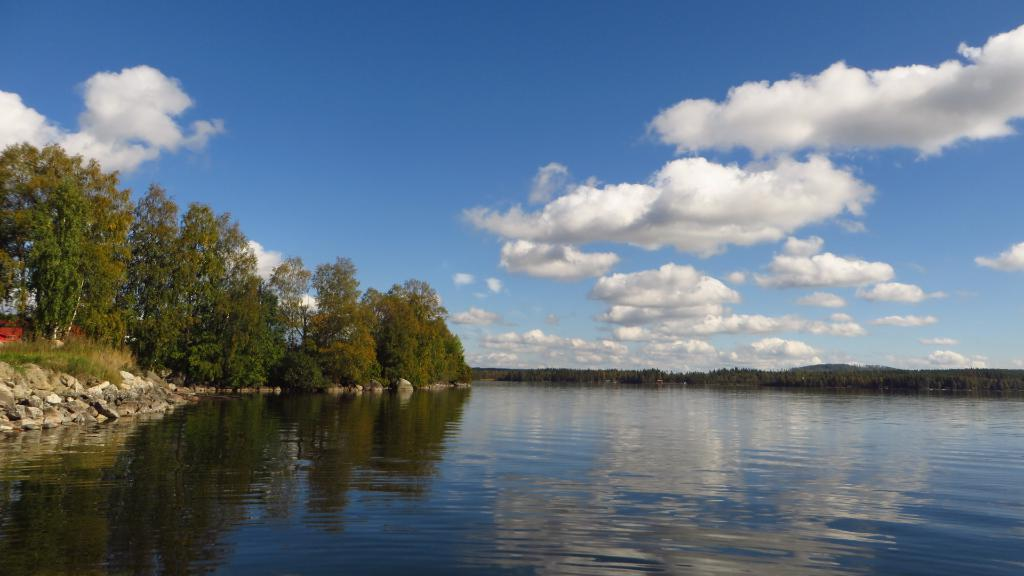What is one of the natural elements present in the image? There is water in the image. What type of terrain can be seen in the image? There are stones and grass in the image. What type of vegetation is present in the image? There are trees in the image. What is visible in the background of the image? The sky is visible in the background of the image. What can be observed in the sky? There are clouds in the sky. What type of trade is happening between the clouds and the trees in the image? There is no trade happening between the clouds and the trees in the image; they are separate elements in the scene. 